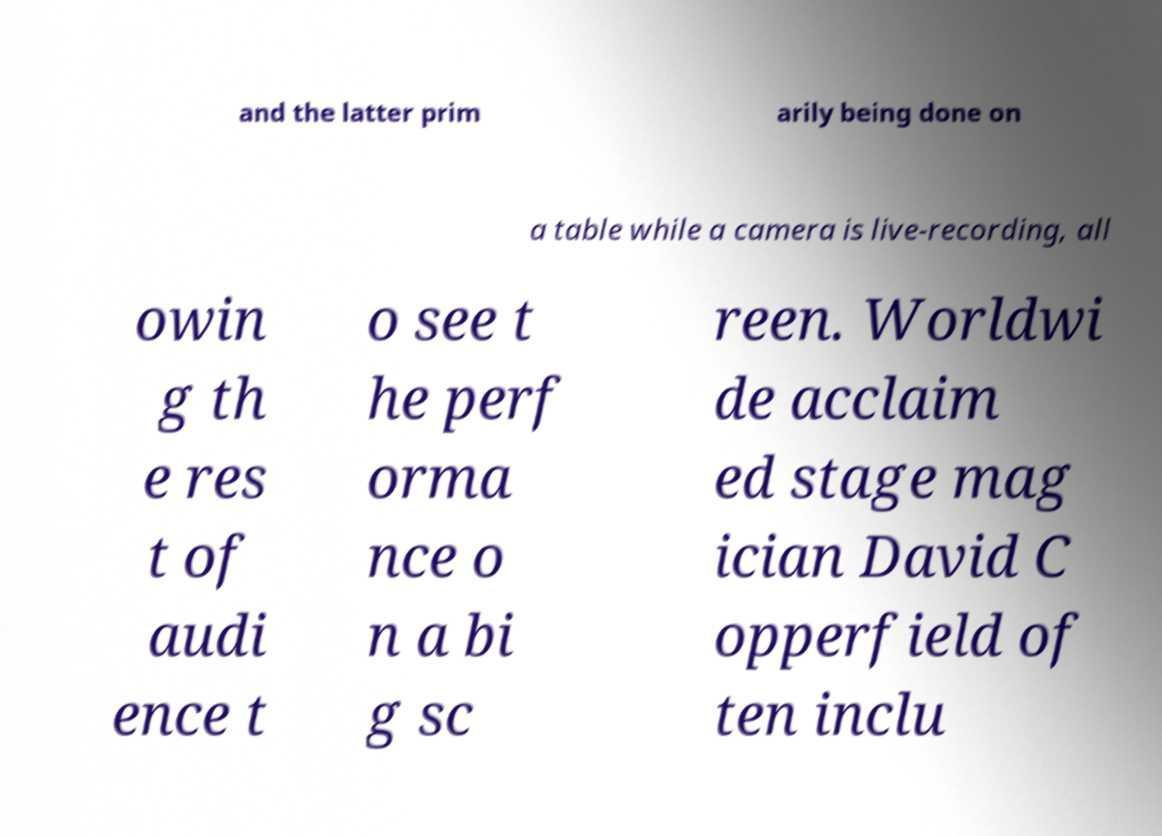Please read and relay the text visible in this image. What does it say? and the latter prim arily being done on a table while a camera is live-recording, all owin g th e res t of audi ence t o see t he perf orma nce o n a bi g sc reen. Worldwi de acclaim ed stage mag ician David C opperfield of ten inclu 